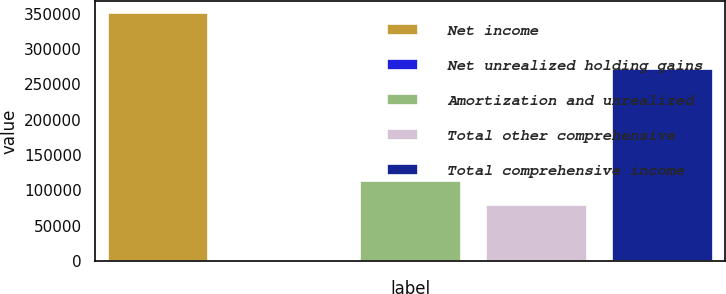<chart> <loc_0><loc_0><loc_500><loc_500><bar_chart><fcel>Net income<fcel>Net unrealized holding gains<fcel>Amortization and unrealized<fcel>Total other comprehensive<fcel>Total comprehensive income<nl><fcel>350104<fcel>465<fcel>113656<fcel>78692<fcel>271412<nl></chart> 